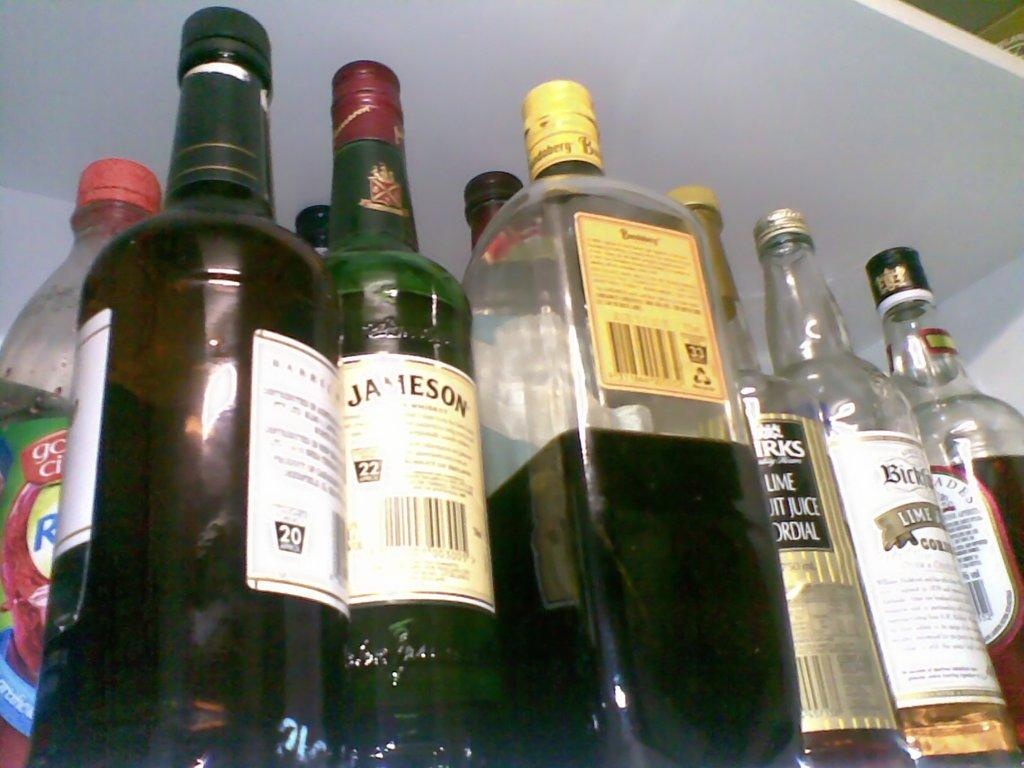<image>
Offer a succinct explanation of the picture presented. A selection of drinks including one from the brand Jameson. 